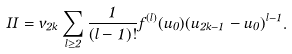Convert formula to latex. <formula><loc_0><loc_0><loc_500><loc_500>I I = v _ { 2 k } \sum _ { l \geq 2 } \frac { 1 } { ( l - 1 ) ! } f ^ { ( l ) } ( u _ { 0 } ) ( u _ { 2 k - 1 } - u _ { 0 } ) ^ { l - 1 } .</formula> 